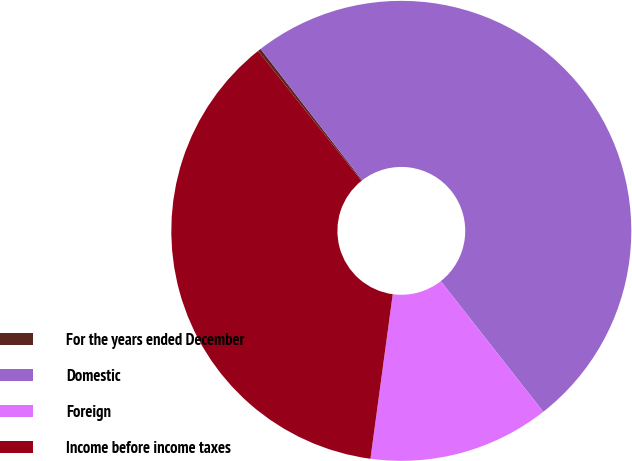Convert chart. <chart><loc_0><loc_0><loc_500><loc_500><pie_chart><fcel>For the years ended December<fcel>Domestic<fcel>Foreign<fcel>Income before income taxes<nl><fcel>0.22%<fcel>49.89%<fcel>12.73%<fcel>37.16%<nl></chart> 